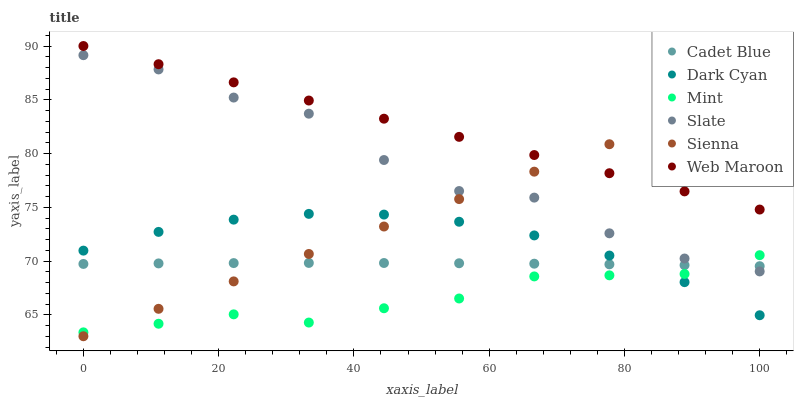Does Mint have the minimum area under the curve?
Answer yes or no. Yes. Does Web Maroon have the maximum area under the curve?
Answer yes or no. Yes. Does Slate have the minimum area under the curve?
Answer yes or no. No. Does Slate have the maximum area under the curve?
Answer yes or no. No. Is Web Maroon the smoothest?
Answer yes or no. Yes. Is Slate the roughest?
Answer yes or no. Yes. Is Slate the smoothest?
Answer yes or no. No. Is Web Maroon the roughest?
Answer yes or no. No. Does Sienna have the lowest value?
Answer yes or no. Yes. Does Slate have the lowest value?
Answer yes or no. No. Does Web Maroon have the highest value?
Answer yes or no. Yes. Does Slate have the highest value?
Answer yes or no. No. Is Slate less than Web Maroon?
Answer yes or no. Yes. Is Web Maroon greater than Dark Cyan?
Answer yes or no. Yes. Does Mint intersect Slate?
Answer yes or no. Yes. Is Mint less than Slate?
Answer yes or no. No. Is Mint greater than Slate?
Answer yes or no. No. Does Slate intersect Web Maroon?
Answer yes or no. No. 